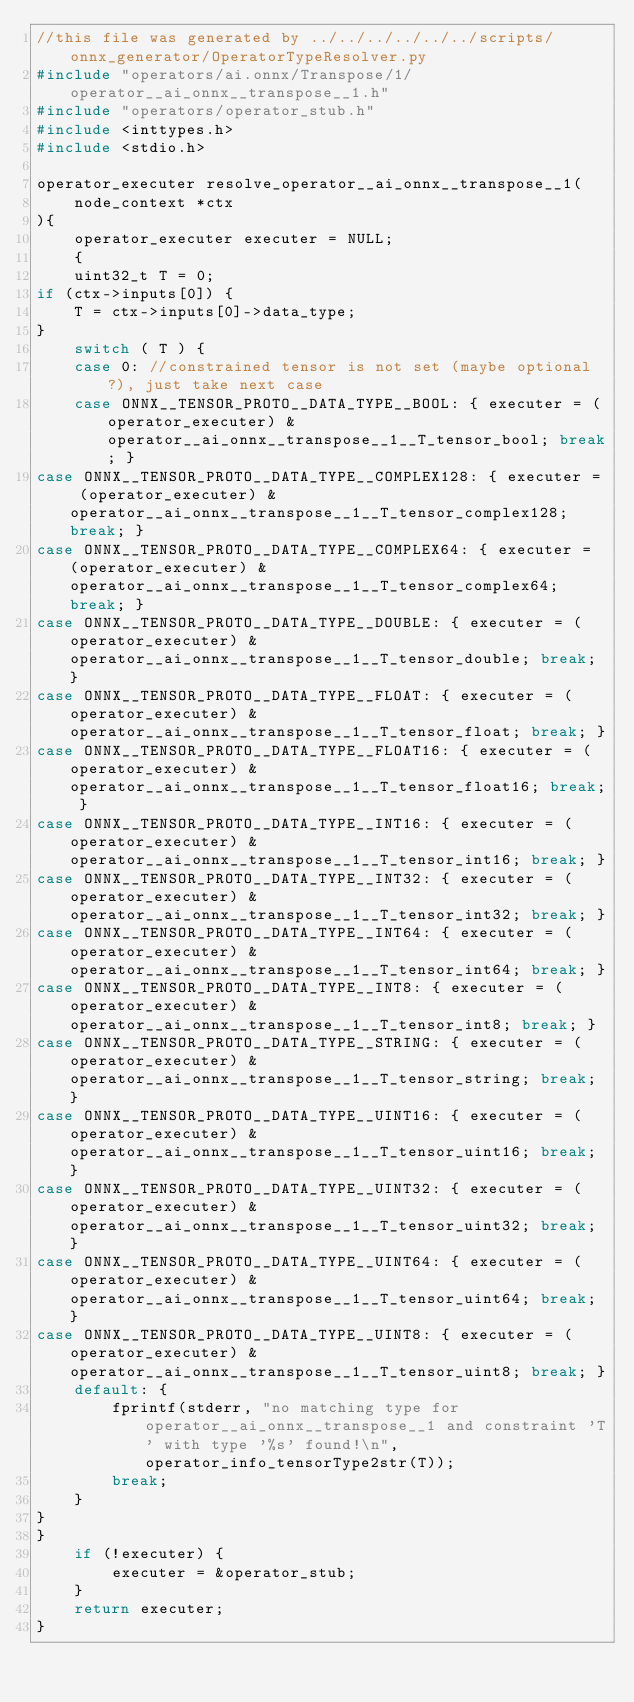<code> <loc_0><loc_0><loc_500><loc_500><_C_>//this file was generated by ../../../../../../scripts/onnx_generator/OperatorTypeResolver.py
#include "operators/ai.onnx/Transpose/1/operator__ai_onnx__transpose__1.h"
#include "operators/operator_stub.h"
#include <inttypes.h>
#include <stdio.h>

operator_executer resolve_operator__ai_onnx__transpose__1(
    node_context *ctx
){
    operator_executer executer = NULL;
    {
    uint32_t T = 0;
if (ctx->inputs[0]) {
    T = ctx->inputs[0]->data_type;
}
    switch ( T ) {
    case 0: //constrained tensor is not set (maybe optional?), just take next case
    case ONNX__TENSOR_PROTO__DATA_TYPE__BOOL: { executer = (operator_executer) &operator__ai_onnx__transpose__1__T_tensor_bool; break; }
case ONNX__TENSOR_PROTO__DATA_TYPE__COMPLEX128: { executer = (operator_executer) &operator__ai_onnx__transpose__1__T_tensor_complex128; break; }
case ONNX__TENSOR_PROTO__DATA_TYPE__COMPLEX64: { executer = (operator_executer) &operator__ai_onnx__transpose__1__T_tensor_complex64; break; }
case ONNX__TENSOR_PROTO__DATA_TYPE__DOUBLE: { executer = (operator_executer) &operator__ai_onnx__transpose__1__T_tensor_double; break; }
case ONNX__TENSOR_PROTO__DATA_TYPE__FLOAT: { executer = (operator_executer) &operator__ai_onnx__transpose__1__T_tensor_float; break; }
case ONNX__TENSOR_PROTO__DATA_TYPE__FLOAT16: { executer = (operator_executer) &operator__ai_onnx__transpose__1__T_tensor_float16; break; }
case ONNX__TENSOR_PROTO__DATA_TYPE__INT16: { executer = (operator_executer) &operator__ai_onnx__transpose__1__T_tensor_int16; break; }
case ONNX__TENSOR_PROTO__DATA_TYPE__INT32: { executer = (operator_executer) &operator__ai_onnx__transpose__1__T_tensor_int32; break; }
case ONNX__TENSOR_PROTO__DATA_TYPE__INT64: { executer = (operator_executer) &operator__ai_onnx__transpose__1__T_tensor_int64; break; }
case ONNX__TENSOR_PROTO__DATA_TYPE__INT8: { executer = (operator_executer) &operator__ai_onnx__transpose__1__T_tensor_int8; break; }
case ONNX__TENSOR_PROTO__DATA_TYPE__STRING: { executer = (operator_executer) &operator__ai_onnx__transpose__1__T_tensor_string; break; }
case ONNX__TENSOR_PROTO__DATA_TYPE__UINT16: { executer = (operator_executer) &operator__ai_onnx__transpose__1__T_tensor_uint16; break; }
case ONNX__TENSOR_PROTO__DATA_TYPE__UINT32: { executer = (operator_executer) &operator__ai_onnx__transpose__1__T_tensor_uint32; break; }
case ONNX__TENSOR_PROTO__DATA_TYPE__UINT64: { executer = (operator_executer) &operator__ai_onnx__transpose__1__T_tensor_uint64; break; }
case ONNX__TENSOR_PROTO__DATA_TYPE__UINT8: { executer = (operator_executer) &operator__ai_onnx__transpose__1__T_tensor_uint8; break; }
    default: {
        fprintf(stderr, "no matching type for operator__ai_onnx__transpose__1 and constraint 'T' with type '%s' found!\n",operator_info_tensorType2str(T));
        break;
    }
}
}
    if (!executer) {
        executer = &operator_stub;
    }
    return executer;
}</code> 